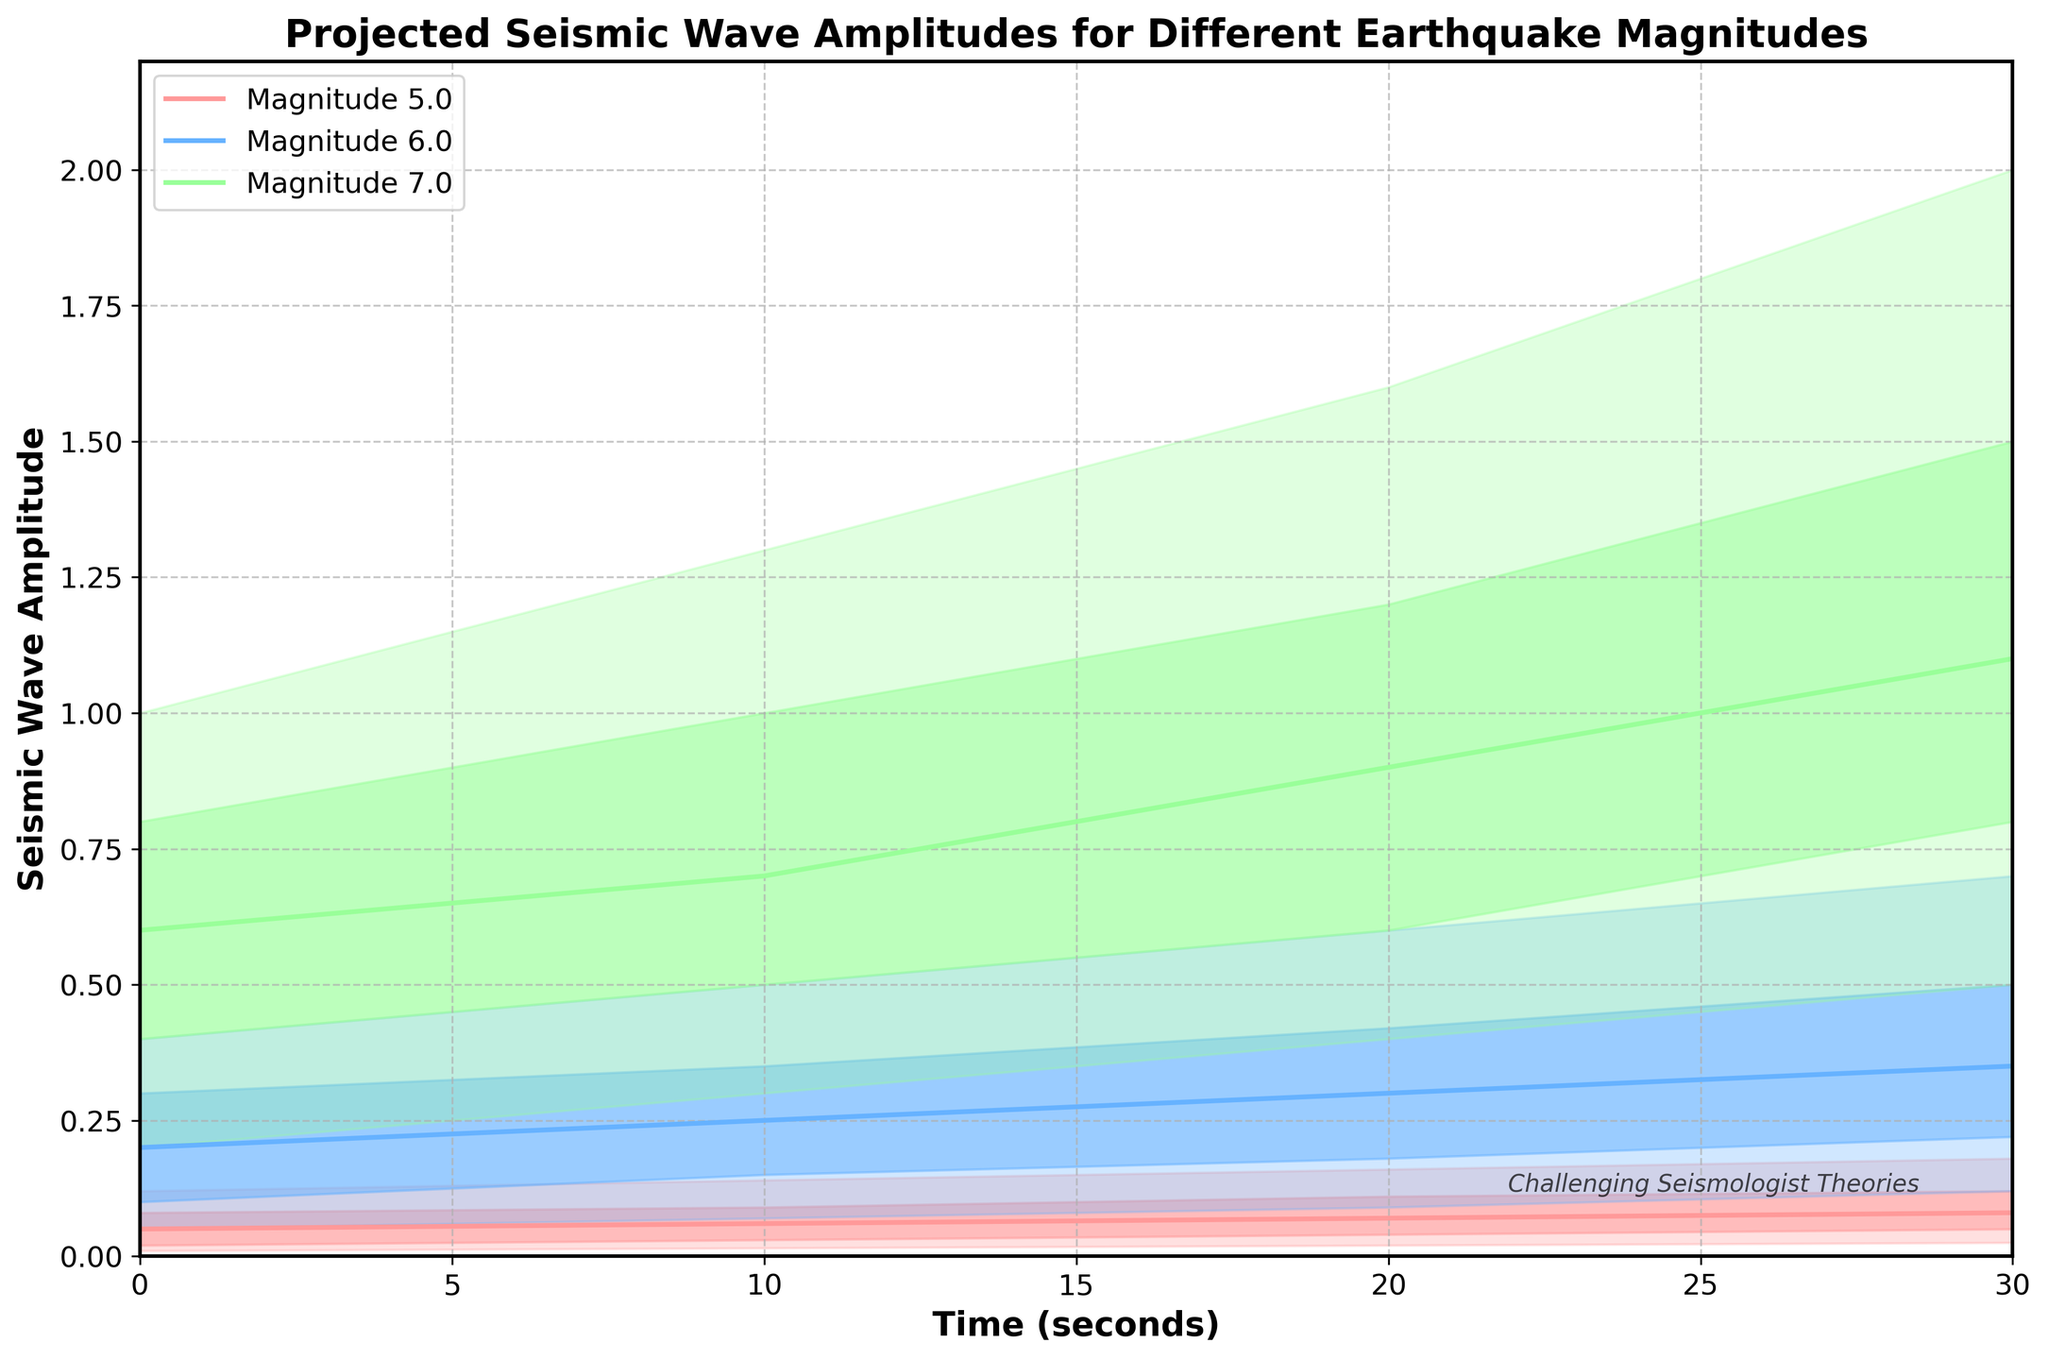What is the title of the figure? The title is located at the top of the figure. It provides a concise summary of what the graph is about.
Answer: Projected Seismic Wave Amplitudes for Different Earthquake Magnitudes How many different earthquake magnitudes are represented in the figure? Each different earthquake magnitude is represented by a distinct set of data points and separate lines on the plot. By counting these sets, we can determine the number of different magnitudes.
Answer: 3 What does the label on the x-axis represent? The label on the x-axis is found at the bottom of the figure and indicates what the horizontal axis measurements correspond to.
Answer: Time (seconds) Which magnitude shows the highest projected seismic wave amplitude at time 20 seconds according to the median (P50) value? To answer this, look at the P50 (median) line for each magnitude at the 20-second mark and compare their values. The highest of these values corresponds to the highest projected amplitude.
Answer: 7.0 What is the range of the projected seismic wave amplitude for magnitude 5.0 at time 10 seconds between the 10th and 90th percentiles (P10 and P90)? Find the values of P10 and P90 for magnitude 5.0 at time 10 seconds and calculate the difference between them.
Answer: 0.125 How does the range of projected seismic wave amplitudes for magnitude 6.0 compare between time 0 and time 30 seconds? Check the values of P10 and P90 for magnitude 6.0 at both time 0 and time 30 seconds and calculate the ranges at these times. Then compare these ranges.
Answer: It increases from 0.35 to 0.58 Which magnitude shows the steepest increase in the median amplitude (P50) from time 0 to time 30 seconds? For each magnitude, check the P50 values at time 0 and time 30 seconds and calculate the difference. The magnitude with the highest difference shows the steepest increase.
Answer: 7.0 What trend can be observed in the projected seismic wave amplitudes for magnitude 6.0 over time? Observing the lines and shaded areas for magnitude 6.0, note any increase or decrease in amplitude values over time, as well as the spread of the percentiles.
Answer: Increasing amplitudes At time 10 seconds, which magnitude has the smallest interquartile range (IQR) for projected seismic wave amplitude? IQR is the difference between P75 and P25 values. Calculate IQR for each magnitude at time 10 seconds and compare to find the smallest.
Answer: 5.0 How do the uncertainty ranges (P10 to P90) for the amplitude projections at time 30 seconds compare across different magnitudes? Examine the width of the shaded areas representing the range from P10 to P90 for each magnitude at the time 30-second mark and compare them.
Answer: Magnitude 7.0 has the largest range, followed by 6.0, then 5.0 